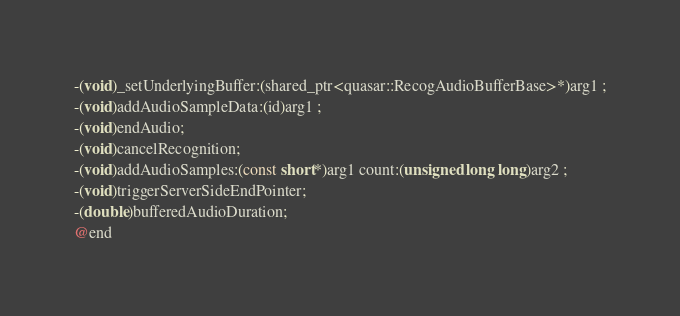<code> <loc_0><loc_0><loc_500><loc_500><_C_>-(void)_setUnderlyingBuffer:(shared_ptr<quasar::RecogAudioBufferBase>*)arg1 ;
-(void)addAudioSampleData:(id)arg1 ;
-(void)endAudio;
-(void)cancelRecognition;
-(void)addAudioSamples:(const short*)arg1 count:(unsigned long long)arg2 ;
-(void)triggerServerSideEndPointer;
-(double)bufferedAudioDuration;
@end

</code> 